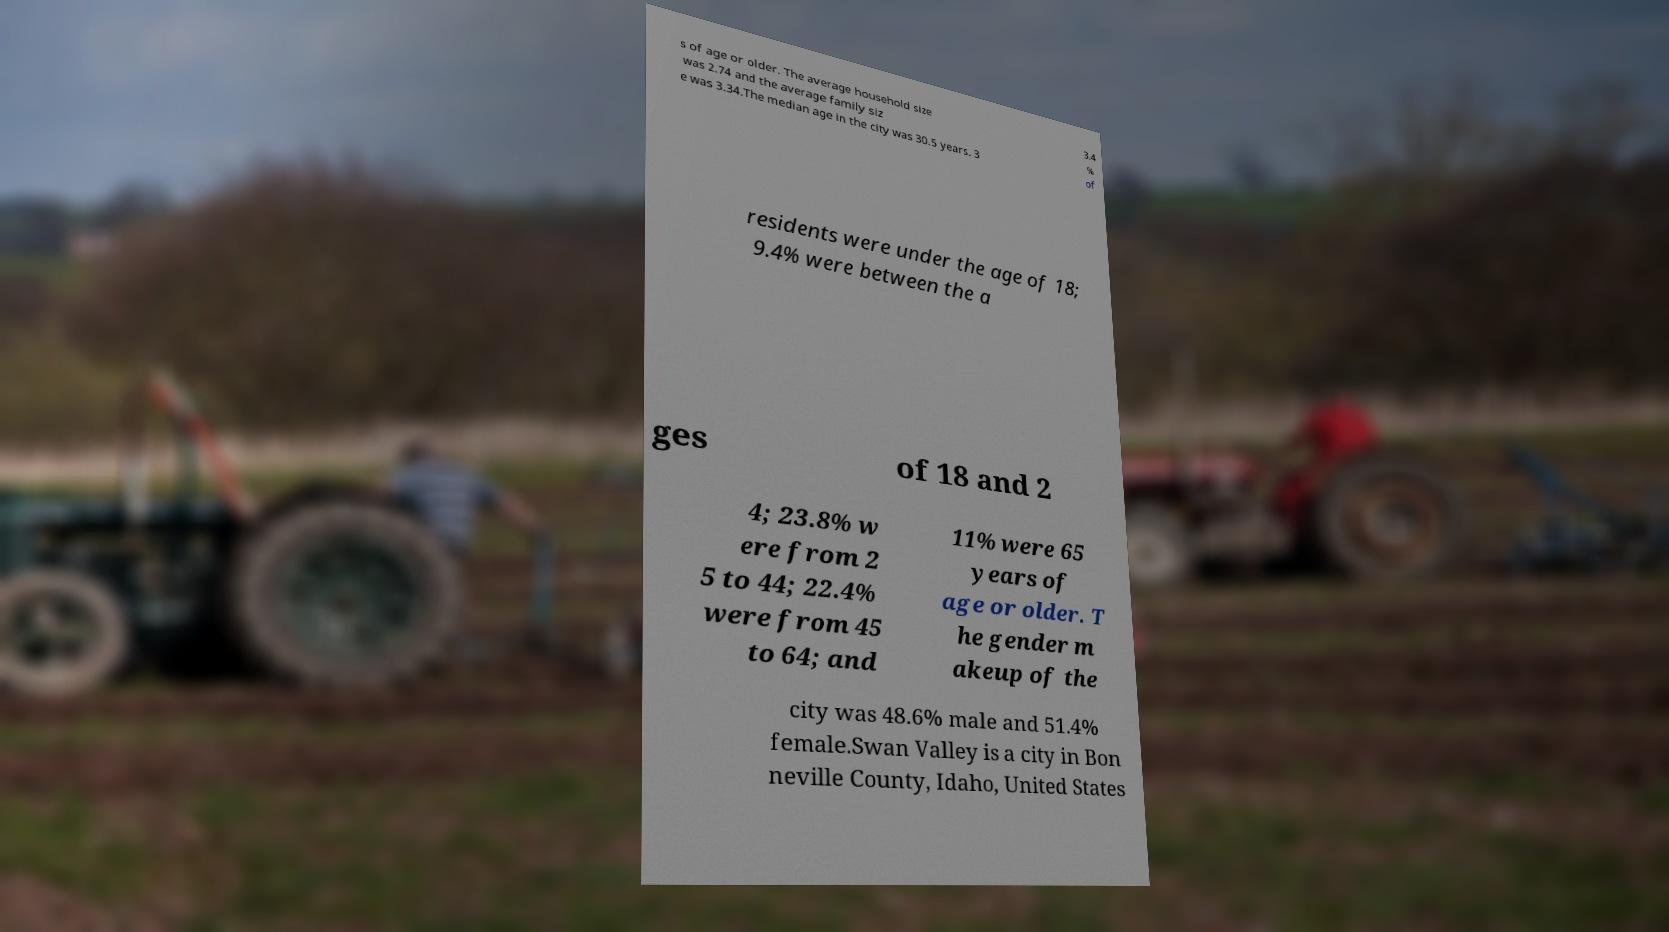Could you extract and type out the text from this image? s of age or older. The average household size was 2.74 and the average family siz e was 3.34.The median age in the city was 30.5 years. 3 3.4 % of residents were under the age of 18; 9.4% were between the a ges of 18 and 2 4; 23.8% w ere from 2 5 to 44; 22.4% were from 45 to 64; and 11% were 65 years of age or older. T he gender m akeup of the city was 48.6% male and 51.4% female.Swan Valley is a city in Bon neville County, Idaho, United States 